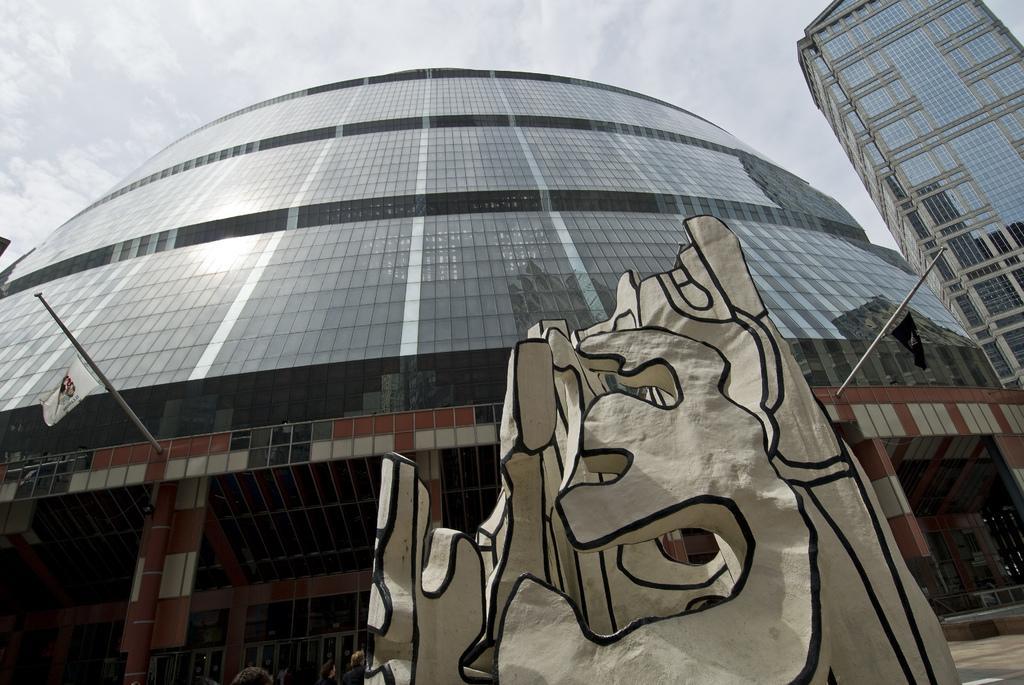How would you summarize this image in a sentence or two? This picture is clicked outside the city. In the foreground we can see there are some objects placed on the ground. In the background we can see the buildings, metal rods, flags and the sky. 